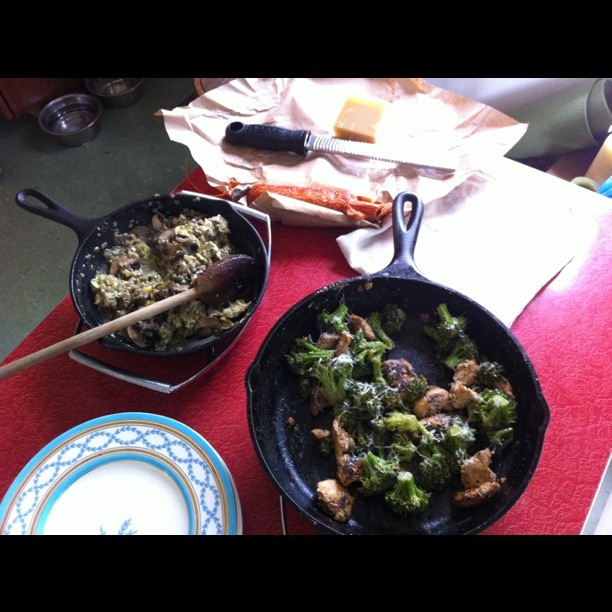<image>What color are the chopsticks? There are no chopsticks in the image. However, they can be brown, beige, or tan. What activity is being shown in the pictures? It is ambiguous what activity is being shown in the picture. It could either be eating or cooking. What color are the chopsticks? The chopsticks are tan in color. What activity is being shown in the pictures? I am not sure what activity is being shown in the pictures. It can be seen 'dinner', 'eating', or 'cooking'. 